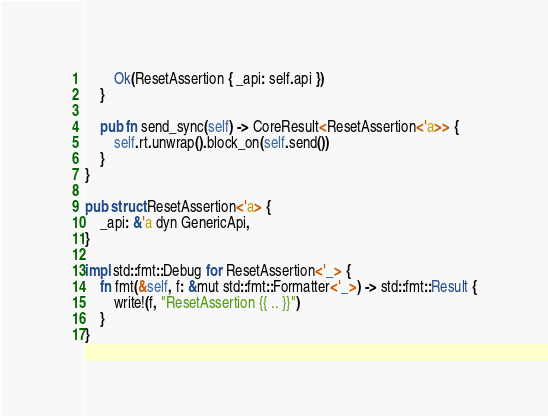Convert code to text. <code><loc_0><loc_0><loc_500><loc_500><_Rust_>        Ok(ResetAssertion { _api: self.api })
    }

    pub fn send_sync(self) -> CoreResult<ResetAssertion<'a>> {
        self.rt.unwrap().block_on(self.send())
    }
}

pub struct ResetAssertion<'a> {
    _api: &'a dyn GenericApi,
}

impl std::fmt::Debug for ResetAssertion<'_> {
    fn fmt(&self, f: &mut std::fmt::Formatter<'_>) -> std::fmt::Result {
        write!(f, "ResetAssertion {{ .. }}")
    }
}
</code> 